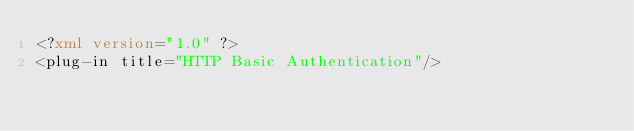<code> <loc_0><loc_0><loc_500><loc_500><_XML_><?xml version="1.0" ?>
<plug-in title="HTTP Basic Authentication"/>
</code> 